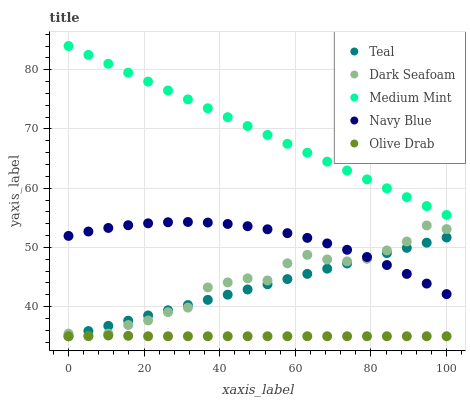Does Olive Drab have the minimum area under the curve?
Answer yes or no. Yes. Does Medium Mint have the maximum area under the curve?
Answer yes or no. Yes. Does Navy Blue have the minimum area under the curve?
Answer yes or no. No. Does Navy Blue have the maximum area under the curve?
Answer yes or no. No. Is Teal the smoothest?
Answer yes or no. Yes. Is Dark Seafoam the roughest?
Answer yes or no. Yes. Is Navy Blue the smoothest?
Answer yes or no. No. Is Navy Blue the roughest?
Answer yes or no. No. Does Dark Seafoam have the lowest value?
Answer yes or no. Yes. Does Navy Blue have the lowest value?
Answer yes or no. No. Does Medium Mint have the highest value?
Answer yes or no. Yes. Does Navy Blue have the highest value?
Answer yes or no. No. Is Olive Drab less than Medium Mint?
Answer yes or no. Yes. Is Medium Mint greater than Dark Seafoam?
Answer yes or no. Yes. Does Navy Blue intersect Dark Seafoam?
Answer yes or no. Yes. Is Navy Blue less than Dark Seafoam?
Answer yes or no. No. Is Navy Blue greater than Dark Seafoam?
Answer yes or no. No. Does Olive Drab intersect Medium Mint?
Answer yes or no. No. 